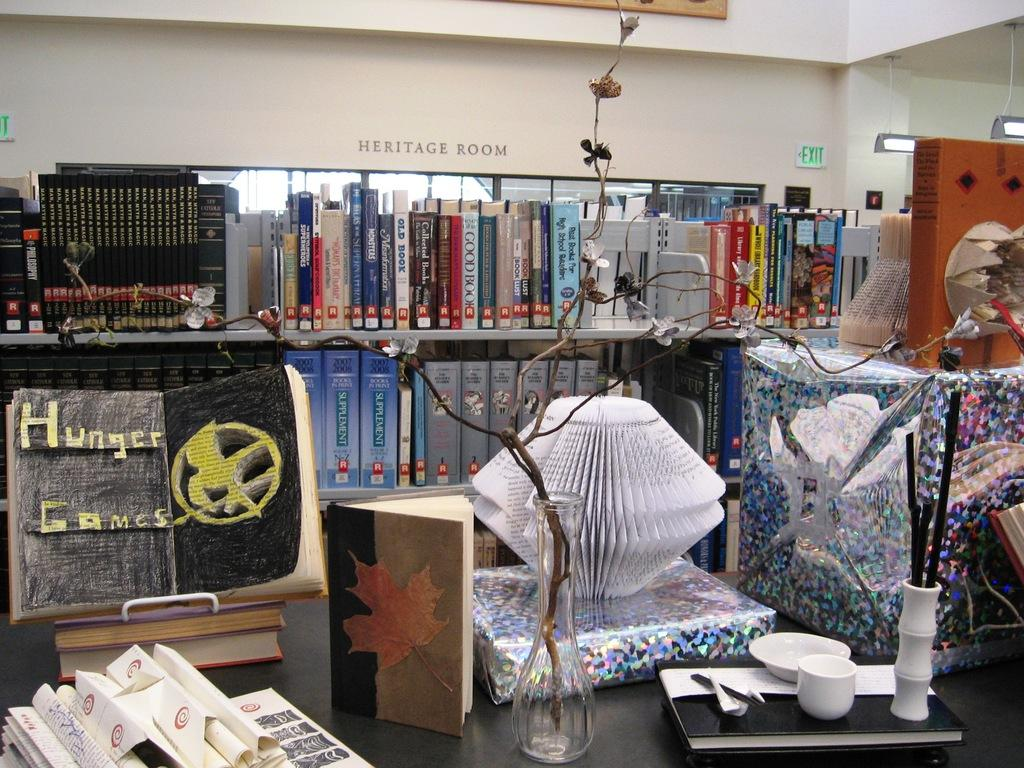<image>
Create a compact narrative representing the image presented. The heritage room at the library features some artwork in addition to books. 